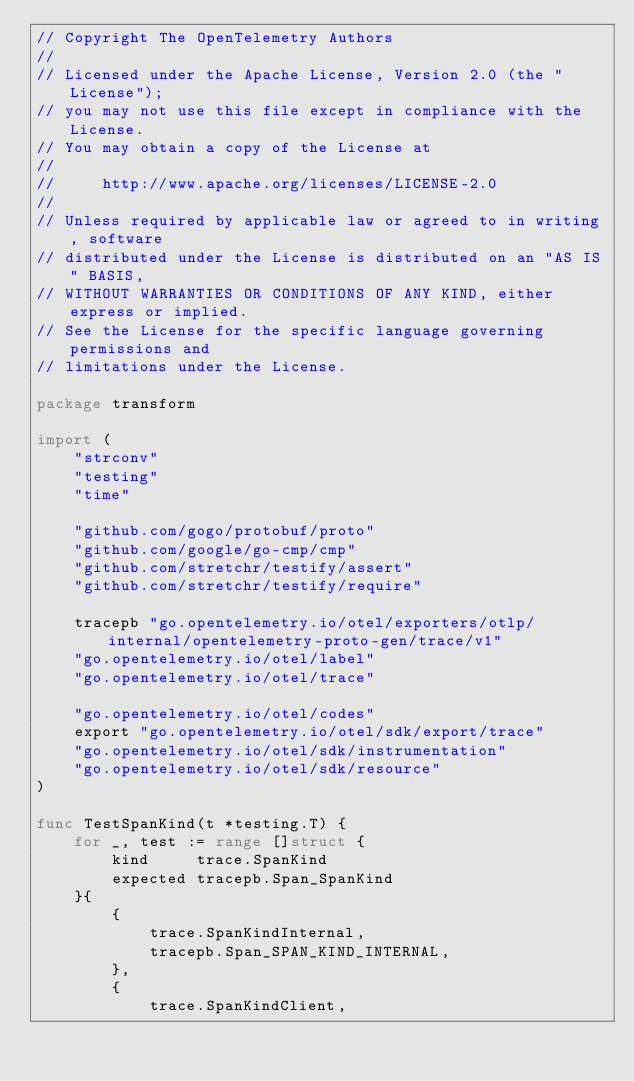Convert code to text. <code><loc_0><loc_0><loc_500><loc_500><_Go_>// Copyright The OpenTelemetry Authors
//
// Licensed under the Apache License, Version 2.0 (the "License");
// you may not use this file except in compliance with the License.
// You may obtain a copy of the License at
//
//     http://www.apache.org/licenses/LICENSE-2.0
//
// Unless required by applicable law or agreed to in writing, software
// distributed under the License is distributed on an "AS IS" BASIS,
// WITHOUT WARRANTIES OR CONDITIONS OF ANY KIND, either express or implied.
// See the License for the specific language governing permissions and
// limitations under the License.

package transform

import (
	"strconv"
	"testing"
	"time"

	"github.com/gogo/protobuf/proto"
	"github.com/google/go-cmp/cmp"
	"github.com/stretchr/testify/assert"
	"github.com/stretchr/testify/require"

	tracepb "go.opentelemetry.io/otel/exporters/otlp/internal/opentelemetry-proto-gen/trace/v1"
	"go.opentelemetry.io/otel/label"
	"go.opentelemetry.io/otel/trace"

	"go.opentelemetry.io/otel/codes"
	export "go.opentelemetry.io/otel/sdk/export/trace"
	"go.opentelemetry.io/otel/sdk/instrumentation"
	"go.opentelemetry.io/otel/sdk/resource"
)

func TestSpanKind(t *testing.T) {
	for _, test := range []struct {
		kind     trace.SpanKind
		expected tracepb.Span_SpanKind
	}{
		{
			trace.SpanKindInternal,
			tracepb.Span_SPAN_KIND_INTERNAL,
		},
		{
			trace.SpanKindClient,</code> 